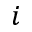Convert formula to latex. <formula><loc_0><loc_0><loc_500><loc_500>i</formula> 